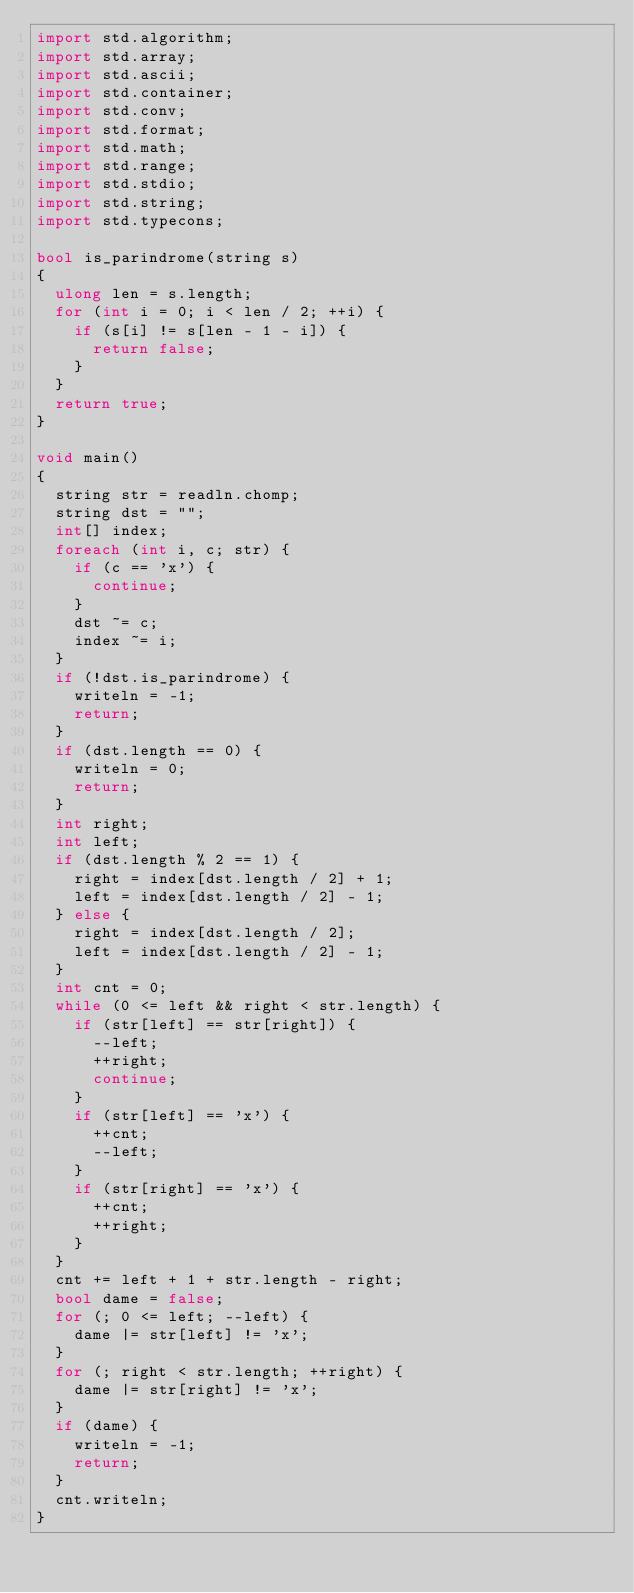<code> <loc_0><loc_0><loc_500><loc_500><_D_>import std.algorithm;
import std.array;
import std.ascii;
import std.container;
import std.conv;
import std.format;
import std.math;
import std.range;
import std.stdio;
import std.string;
import std.typecons;

bool is_parindrome(string s)
{
  ulong len = s.length;
  for (int i = 0; i < len / 2; ++i) {
    if (s[i] != s[len - 1 - i]) {
      return false;
    }
  }
  return true;
}

void main()
{
  string str = readln.chomp;
  string dst = "";
  int[] index;
  foreach (int i, c; str) {
    if (c == 'x') {
      continue;
    }
    dst ~= c;
    index ~= i;
  }
  if (!dst.is_parindrome) {
    writeln = -1;
    return;
  }
  if (dst.length == 0) {
    writeln = 0;
    return;
  }
  int right;
  int left;
  if (dst.length % 2 == 1) {
    right = index[dst.length / 2] + 1;
    left = index[dst.length / 2] - 1;
  } else {
    right = index[dst.length / 2];
    left = index[dst.length / 2] - 1;
  }
  int cnt = 0;
  while (0 <= left && right < str.length) {
    if (str[left] == str[right]) {
      --left;
      ++right;
      continue;
    }
    if (str[left] == 'x') {
      ++cnt;
      --left;
    }
    if (str[right] == 'x') {
      ++cnt;
      ++right;
    }
  }
  cnt += left + 1 + str.length - right;
  bool dame = false;
  for (; 0 <= left; --left) {
    dame |= str[left] != 'x';
  }
  for (; right < str.length; ++right) {
    dame |= str[right] != 'x';
  }
  if (dame) {
    writeln = -1;
    return;
  }
  cnt.writeln;
}
</code> 